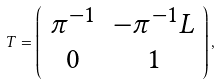Convert formula to latex. <formula><loc_0><loc_0><loc_500><loc_500>T = \left ( \begin{array} { c c } \pi ^ { - 1 } & - \pi ^ { - 1 } L \\ 0 & 1 \end{array} \right ) ,</formula> 